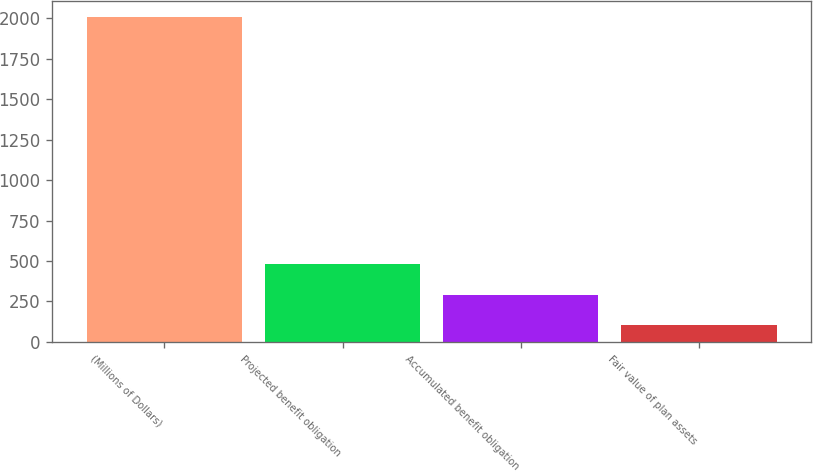Convert chart to OTSL. <chart><loc_0><loc_0><loc_500><loc_500><bar_chart><fcel>(Millions of Dollars)<fcel>Projected benefit obligation<fcel>Accumulated benefit obligation<fcel>Fair value of plan assets<nl><fcel>2005<fcel>482.44<fcel>292.12<fcel>101.8<nl></chart> 